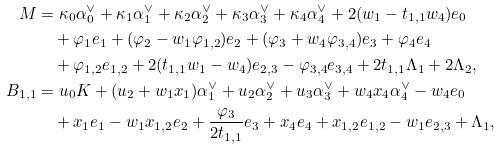<formula> <loc_0><loc_0><loc_500><loc_500>M & = \kappa _ { 0 } \alpha ^ { \vee } _ { 0 } + \kappa _ { 1 } \alpha ^ { \vee } _ { 1 } + \kappa _ { 2 } \alpha ^ { \vee } _ { 2 } + \kappa _ { 3 } \alpha ^ { \vee } _ { 3 } + \kappa _ { 4 } \alpha ^ { \vee } _ { 4 } + 2 ( w _ { 1 } - t _ { 1 , 1 } w _ { 4 } ) e _ { 0 } \\ & \quad + \varphi _ { 1 } e _ { 1 } + ( \varphi _ { 2 } - w _ { 1 } \varphi _ { 1 , 2 } ) e _ { 2 } + ( \varphi _ { 3 } + w _ { 4 } \varphi _ { 3 , 4 } ) e _ { 3 } + \varphi _ { 4 } e _ { 4 } \\ & \quad + \varphi _ { 1 , 2 } e _ { 1 , 2 } + 2 ( t _ { 1 , 1 } w _ { 1 } - w _ { 4 } ) e _ { 2 , 3 } - \varphi _ { 3 , 4 } e _ { 3 , 4 } + 2 t _ { 1 , 1 } \Lambda _ { 1 } + 2 \Lambda _ { 2 } , \\ B _ { 1 , 1 } & = u _ { 0 } K + ( u _ { 2 } + w _ { 1 } x _ { 1 } ) \alpha ^ { \vee } _ { 1 } + u _ { 2 } \alpha ^ { \vee } _ { 2 } + u _ { 3 } \alpha ^ { \vee } _ { 3 } + w _ { 4 } x _ { 4 } \alpha ^ { \vee } _ { 4 } - w _ { 4 } e _ { 0 } \\ & \quad + x _ { 1 } e _ { 1 } - w _ { 1 } x _ { 1 , 2 } e _ { 2 } + \frac { \varphi _ { 3 } } { 2 t _ { 1 , 1 } } e _ { 3 } + x _ { 4 } e _ { 4 } + x _ { 1 , 2 } e _ { 1 , 2 } - w _ { 1 } e _ { 2 , 3 } + \Lambda _ { 1 } ,</formula> 